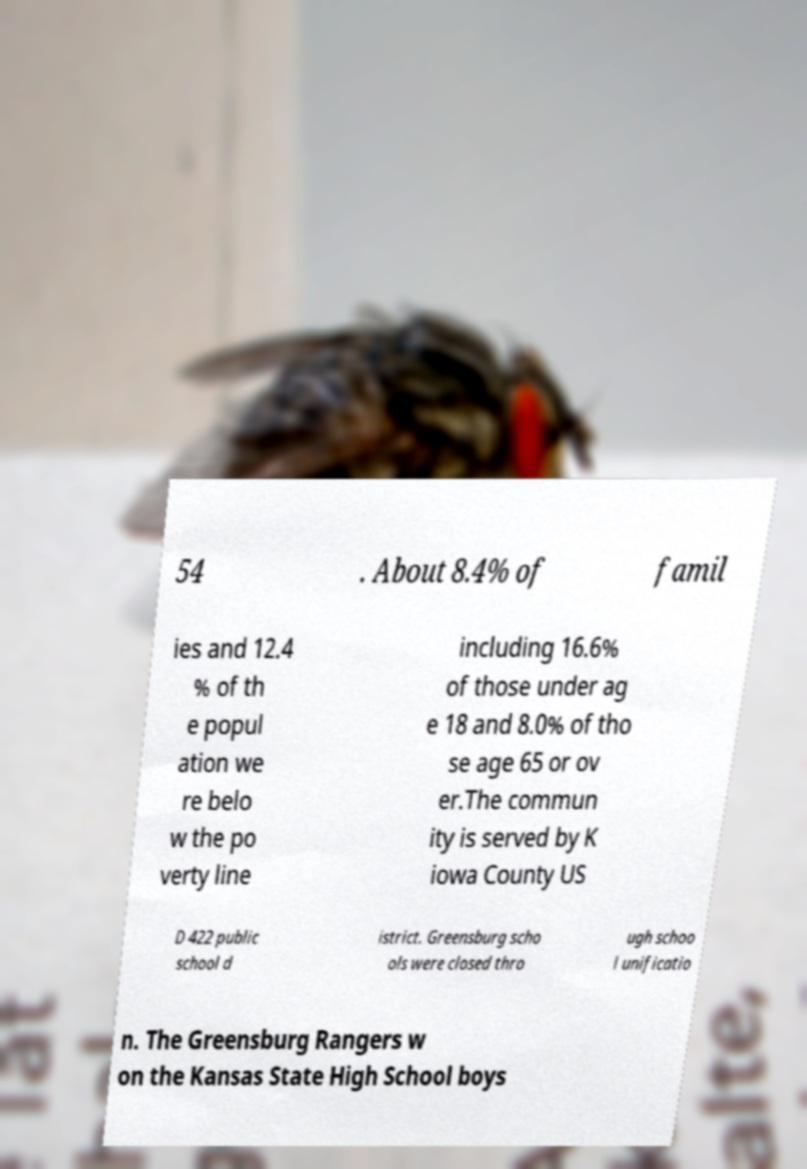There's text embedded in this image that I need extracted. Can you transcribe it verbatim? 54 . About 8.4% of famil ies and 12.4 % of th e popul ation we re belo w the po verty line including 16.6% of those under ag e 18 and 8.0% of tho se age 65 or ov er.The commun ity is served by K iowa County US D 422 public school d istrict. Greensburg scho ols were closed thro ugh schoo l unificatio n. The Greensburg Rangers w on the Kansas State High School boys 